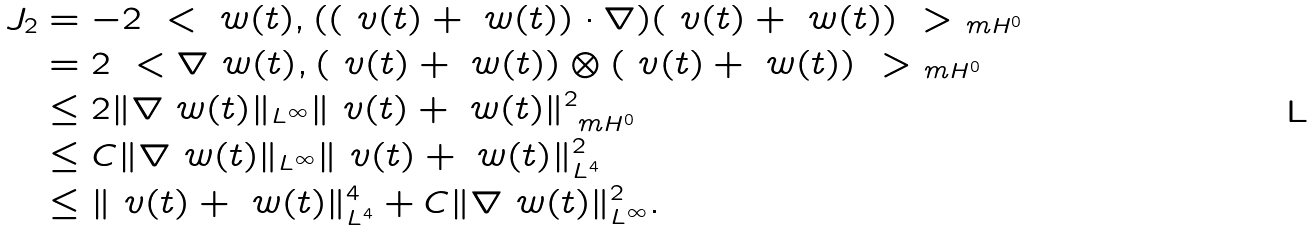<formula> <loc_0><loc_0><loc_500><loc_500>J _ { 2 } & = - 2 \ < \ w ( t ) , ( ( \ v ( t ) + \ w ( t ) ) \cdot \nabla ) ( \ v ( t ) + \ w ( t ) ) \ > _ { \ m H ^ { 0 } } \\ & = 2 \ < \nabla \ w ( t ) , ( \ v ( t ) + \ w ( t ) ) \otimes ( \ v ( t ) + \ w ( t ) ) \ > _ { \ m H ^ { 0 } } \\ & \leq 2 \| \nabla \ w ( t ) \| _ { L ^ { \infty } } \| \ v ( t ) + \ w ( t ) \| ^ { 2 } _ { \ m H ^ { 0 } } \\ & \leq C \| \nabla \ w ( t ) \| _ { L ^ { \infty } } \| \ v ( t ) + \ w ( t ) \| ^ { 2 } _ { L ^ { 4 } } \\ & \leq \| \ v ( t ) + \ w ( t ) \| ^ { 4 } _ { L ^ { 4 } } + C \| \nabla \ w ( t ) \| ^ { 2 } _ { L ^ { \infty } } .</formula> 